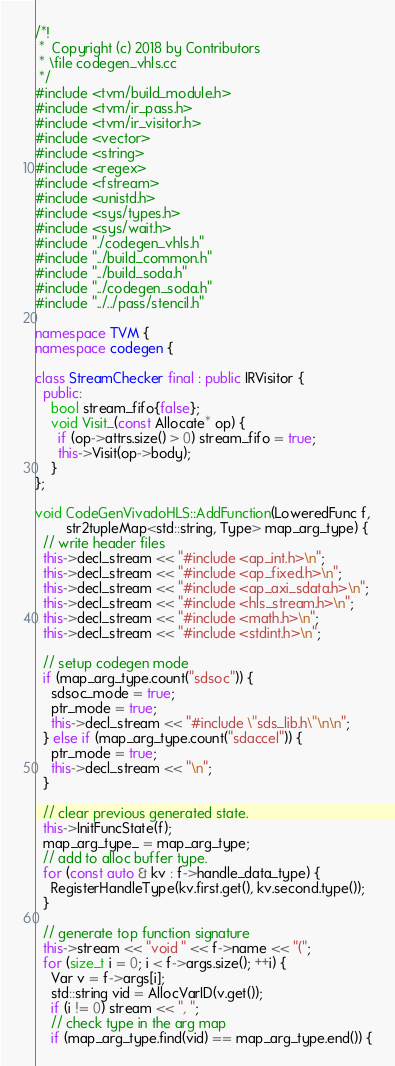Convert code to text. <code><loc_0><loc_0><loc_500><loc_500><_C++_>/*!
 *  Copyright (c) 2018 by Contributors
 * \file codegen_vhls.cc
 */
#include <tvm/build_module.h>
#include <tvm/ir_pass.h>
#include <tvm/ir_visitor.h>
#include <vector>
#include <string>
#include <regex>
#include <fstream>
#include <unistd.h>
#include <sys/types.h>
#include <sys/wait.h>
#include "./codegen_vhls.h"
#include "../build_common.h"
#include "../build_soda.h"
#include "../codegen_soda.h"
#include "../../pass/stencil.h"

namespace TVM {
namespace codegen {

class StreamChecker final : public IRVisitor {
  public:
    bool stream_fifo{false};
    void Visit_(const Allocate* op) {
      if (op->attrs.size() > 0) stream_fifo = true;
      this->Visit(op->body);
    }
};

void CodeGenVivadoHLS::AddFunction(LoweredFunc f,
        str2tupleMap<std::string, Type> map_arg_type) {
  // write header files
  this->decl_stream << "#include <ap_int.h>\n";
  this->decl_stream << "#include <ap_fixed.h>\n";
  this->decl_stream << "#include <ap_axi_sdata.h>\n";
  this->decl_stream << "#include <hls_stream.h>\n";
  this->decl_stream << "#include <math.h>\n";
  this->decl_stream << "#include <stdint.h>\n";

  // setup codegen mode
  if (map_arg_type.count("sdsoc")) {
    sdsoc_mode = true;
    ptr_mode = true;
    this->decl_stream << "#include \"sds_lib.h\"\n\n";
  } else if (map_arg_type.count("sdaccel")) {
    ptr_mode = true;
    this->decl_stream << "\n";
  }

  // clear previous generated state.
  this->InitFuncState(f);
  map_arg_type_ = map_arg_type;
  // add to alloc buffer type.
  for (const auto & kv : f->handle_data_type) {
    RegisterHandleType(kv.first.get(), kv.second.type());
  }

  // generate top function signature
  this->stream << "void " << f->name << "(";
  for (size_t i = 0; i < f->args.size(); ++i) {
    Var v = f->args[i];
    std::string vid = AllocVarID(v.get());
    if (i != 0) stream << ", ";
    // check type in the arg map
    if (map_arg_type.find(vid) == map_arg_type.end()) {</code> 